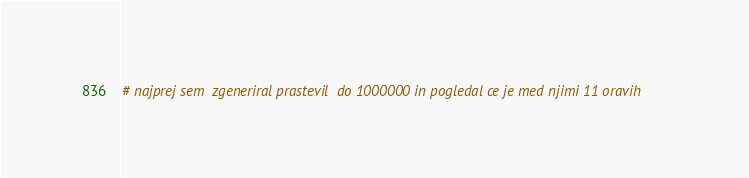<code> <loc_0><loc_0><loc_500><loc_500><_Python_># najprej sem  zgeneriral prastevil  do 1000000 in pogledal ce je med njimi 11 oravih
</code> 